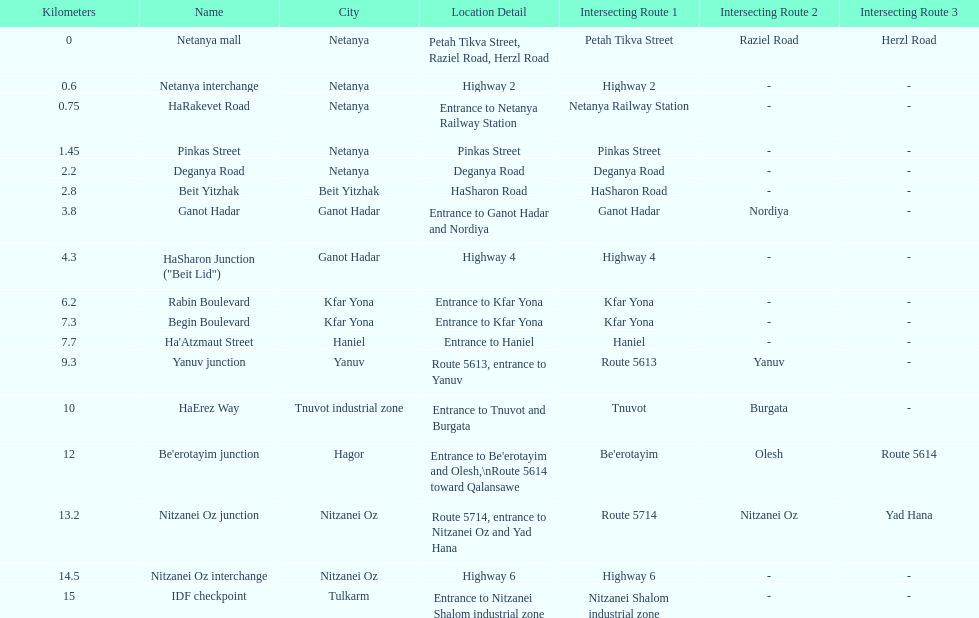I'm looking to parse the entire table for insights. Could you assist me with that? {'header': ['Kilometers', 'Name', 'City', 'Location Detail', 'Intersecting Route 1', 'Intersecting Route 2', 'Intersecting Route 3'], 'rows': [['0', 'Netanya mall', 'Netanya', 'Petah Tikva Street, Raziel Road, Herzl Road', 'Petah Tikva Street', 'Raziel Road', 'Herzl Road'], ['0.6', 'Netanya interchange', 'Netanya', 'Highway 2', 'Highway 2', '-', '-'], ['0.75', 'HaRakevet Road', 'Netanya', 'Entrance to Netanya Railway Station', 'Netanya Railway Station', '-', '-'], ['1.45', 'Pinkas Street', 'Netanya', 'Pinkas Street', 'Pinkas Street', '-', '-'], ['2.2', 'Deganya Road', 'Netanya', 'Deganya Road', 'Deganya Road', '-', '-'], ['2.8', 'Beit Yitzhak', 'Beit Yitzhak', 'HaSharon Road', 'HaSharon Road', '-', '-'], ['3.8', 'Ganot Hadar', 'Ganot Hadar', 'Entrance to Ganot Hadar and Nordiya', 'Ganot Hadar', 'Nordiya', '-'], ['4.3', 'HaSharon Junction ("Beit Lid")', 'Ganot Hadar', 'Highway 4', 'Highway 4', '-', '-'], ['6.2', 'Rabin Boulevard', 'Kfar Yona', 'Entrance to Kfar Yona', 'Kfar Yona', '-', '-'], ['7.3', 'Begin Boulevard', 'Kfar Yona', 'Entrance to Kfar Yona', 'Kfar Yona', '-', '-'], ['7.7', "Ha'Atzmaut Street", 'Haniel', 'Entrance to Haniel', 'Haniel', '-', '-'], ['9.3', 'Yanuv junction', 'Yanuv', 'Route 5613, entrance to Yanuv', 'Route 5613', 'Yanuv', '-'], ['10', 'HaErez Way', 'Tnuvot industrial zone', 'Entrance to Tnuvot and Burgata', 'Tnuvot', 'Burgata', '-'], ['12', "Be'erotayim junction", 'Hagor', "Entrance to Be'erotayim and Olesh,\\nRoute 5614 toward Qalansawe", "Be'erotayim", 'Olesh', 'Route 5614'], ['13.2', 'Nitzanei Oz junction', 'Nitzanei Oz', 'Route 5714, entrance to Nitzanei Oz and Yad Hana', 'Route 5714', 'Nitzanei Oz', 'Yad Hana'], ['14.5', 'Nitzanei Oz interchange', 'Nitzanei Oz', 'Highway 6', 'Highway 6', '-', '-'], ['15', 'IDF checkpoint', 'Tulkarm', 'Entrance to Nitzanei Shalom industrial zone', 'Nitzanei Shalom industrial zone', '-', '-']]} How many locations in netanya are there? 5. 